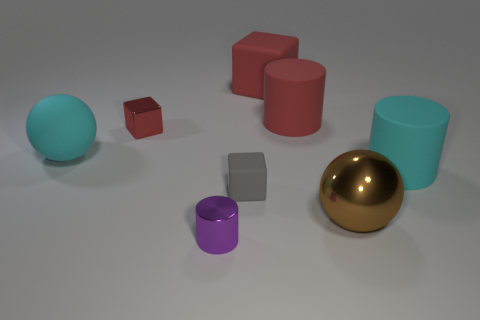Which object stands out the most to you, and can you explain why? The object that stands out the most is the large brown metallic sphere. Its size, combined with its reflective golden surface, draws the eye immediately in contrast to the matte textures and more subdued tones of the other objects in the image. How does the lighting affect the appearance of the objects? The lighting in the image is soft and appears to be coming from above, casting gentle shadows beneath the objects. It highlights the shininess of the metallic sphere and red cube, accentuating their reflective surfaces. The other objects, being matte, reflect less light and therefore look flatter and less pronounced. 